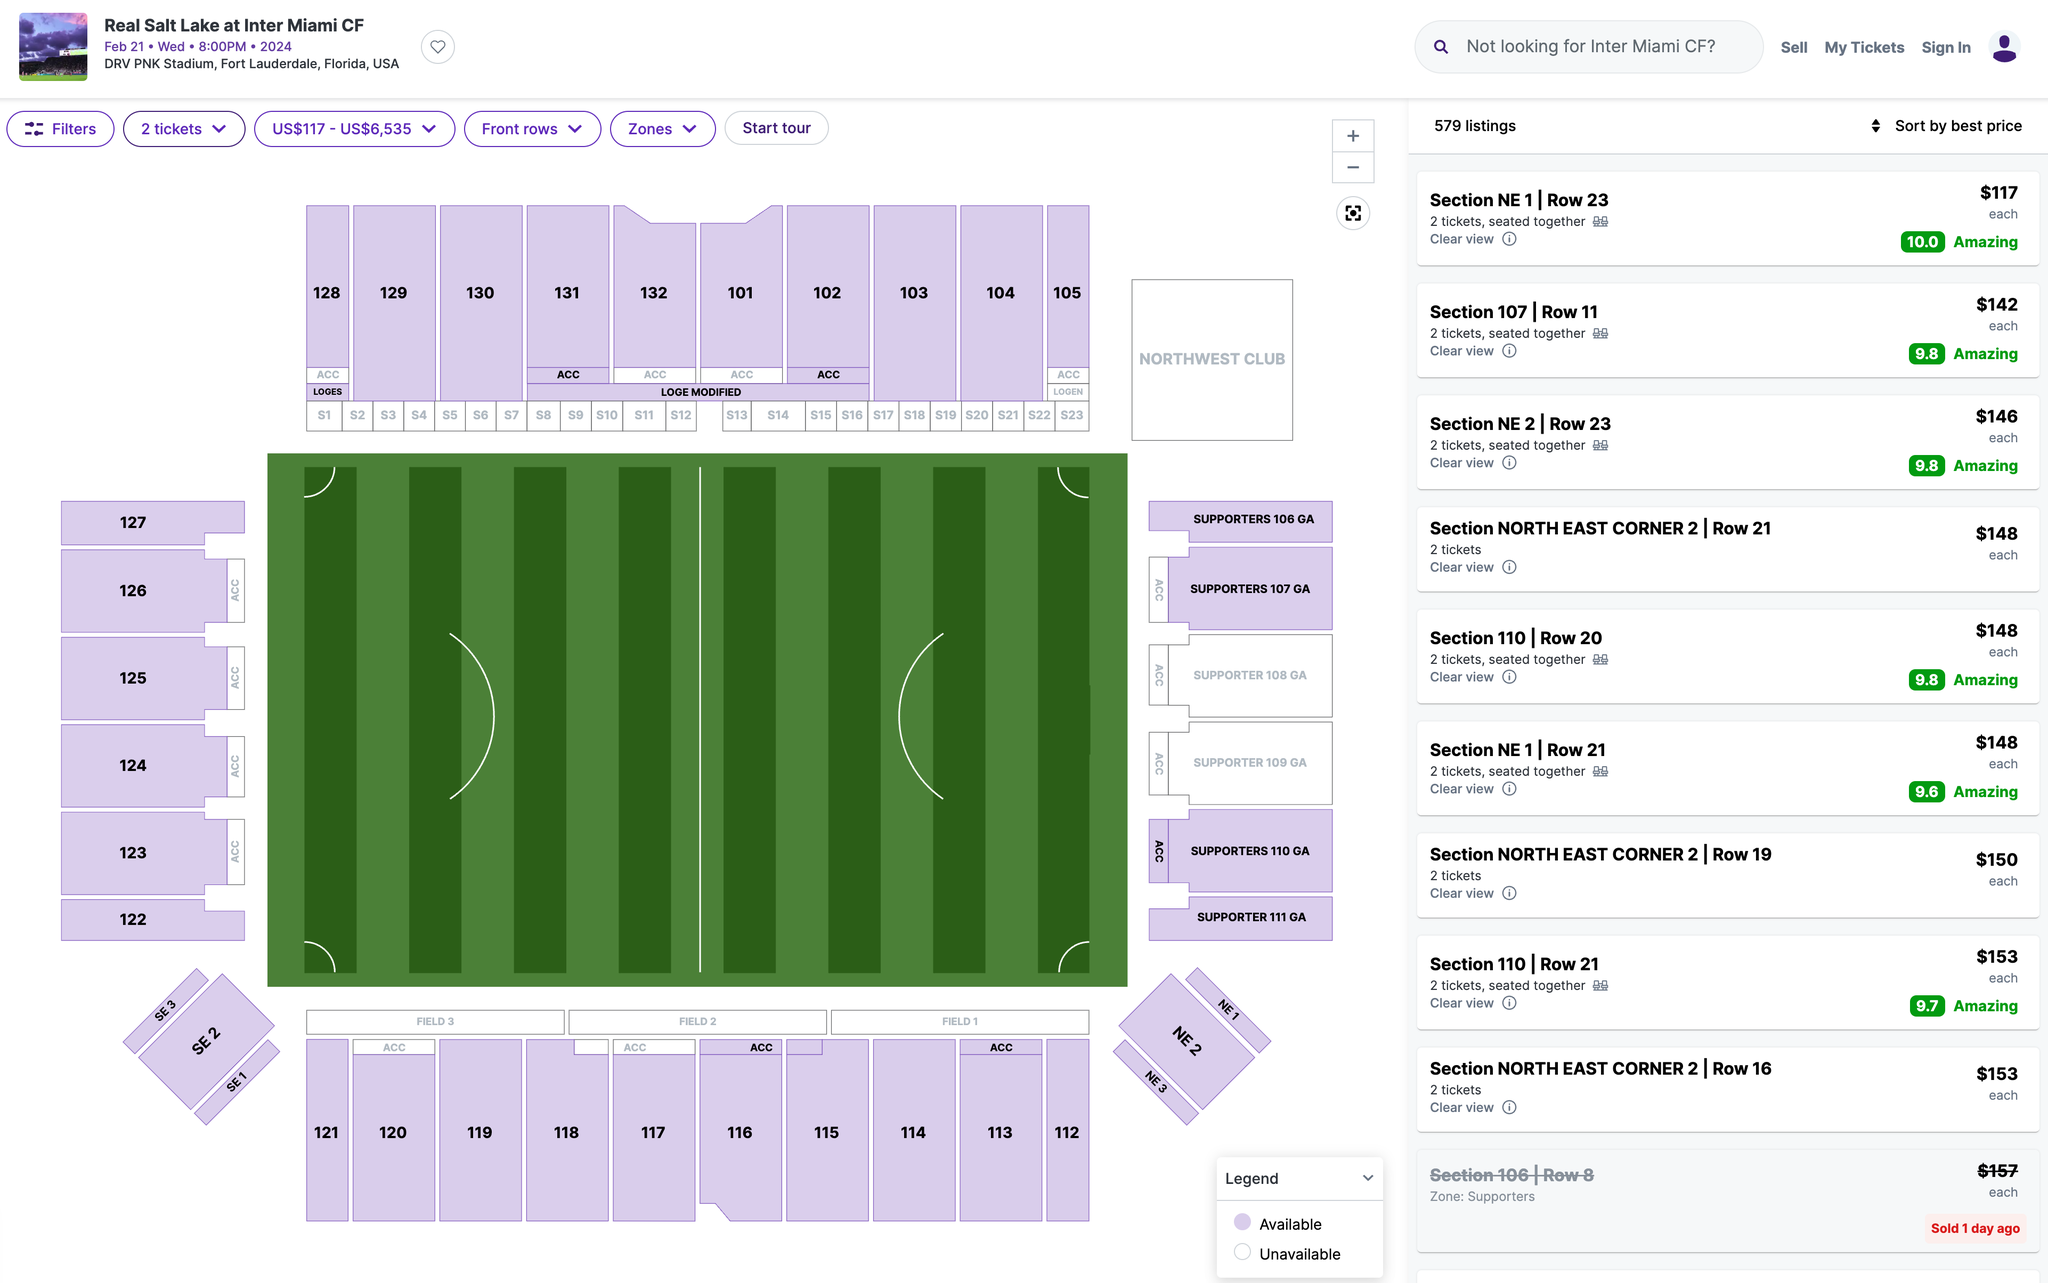Which section's ticket would you recommend I purchase? When choosing a section for a soccer match, there are a few factors to consider, such as your preferred viewing angle, proximity to the field, and the atmosphere you enjoy. Here are some considerations for the sections shown:

1. Sections NE 1 and NE 2 (Northeast Corner): These seats offer a corner view, which can be interesting as you get to see both the goal action and some of the midfield play. They are also elevated, which can give a good perspective of the game's tactics.

2. Section 107: This section is closer to the sideline and would provide a view that's more in line with the midfield. It's a good spot to see player movements across the entire pitch.

3. Supporter Sections (108-111): These are typically the most vibrant and energetic areas of the stadium, with singing, chanting, and standing throughout the match. If you're looking for a lively atmosphere and don't mind standing, these sections can be a lot of fun.

4. Section 110: Located towards the corner but closer to the goal than NE 1/NE 2, this section offers a decent view of goal-line plays on the nearest end and a good angle to see plays develop from the corner.

The "Amazing" ratings next to some section listings suggest that these are considered by the platform to have particularly good views or values. If budget is a concern, you might want to consider the best-rated sections that fit within your price range.

Based on the information provided, if you're looking for a balance between atmosphere and view, and if the price is acceptable to you, Section 107 seems like a solid choice. It's centrally located and the elevation from Row 11 could provide a comprehensive view of the game. However, if you're more interested in being part of the intense fan experience, the Supporter Sections would be the place to be. Ultimately, your personal preference for the experience you're looking for will guide your choice. 